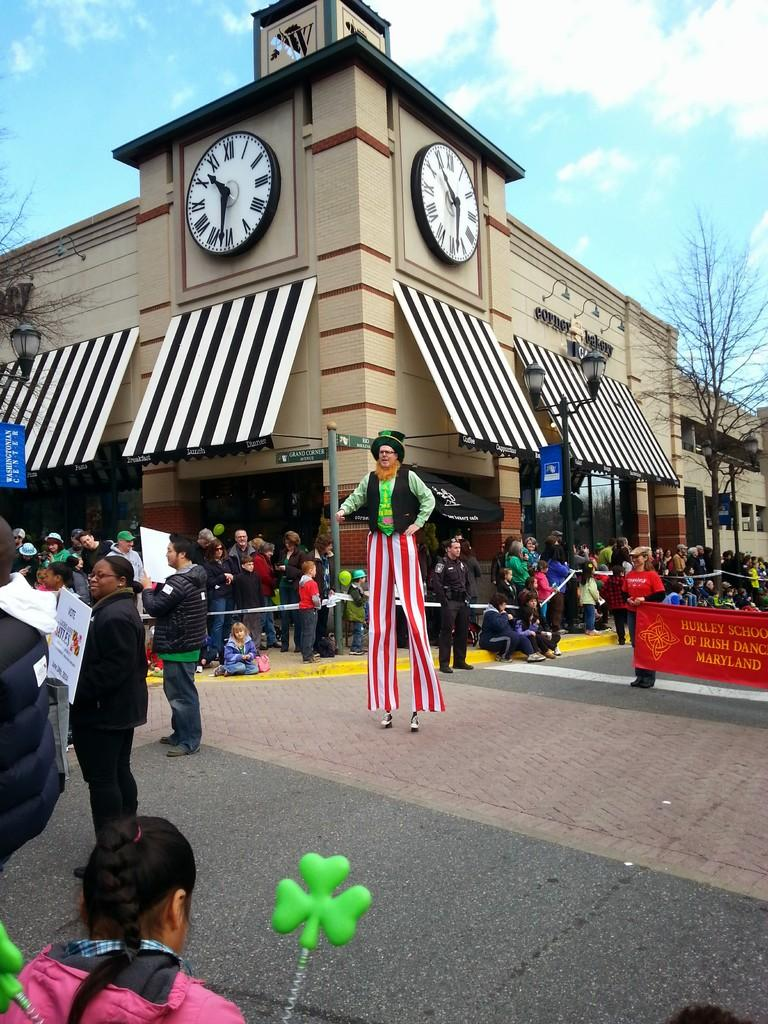What type of structures can be seen in the image? There are buildings in the image. What other natural elements are present in the image? There are trees in the image. Are there any human figures in the image? Yes, there are people in the image. What additional object can be seen in the image? There is a banner in the image. What is the tall, vertical object in the image? There is a pole in the image. What can be seen in the background of the image? The sky is visible in the background of the image. What type of bushes can be seen in the image? There are no bushes present in the image. What does the dad in the image say about the quarter? There is no dad or quarter mentioned in the image. 